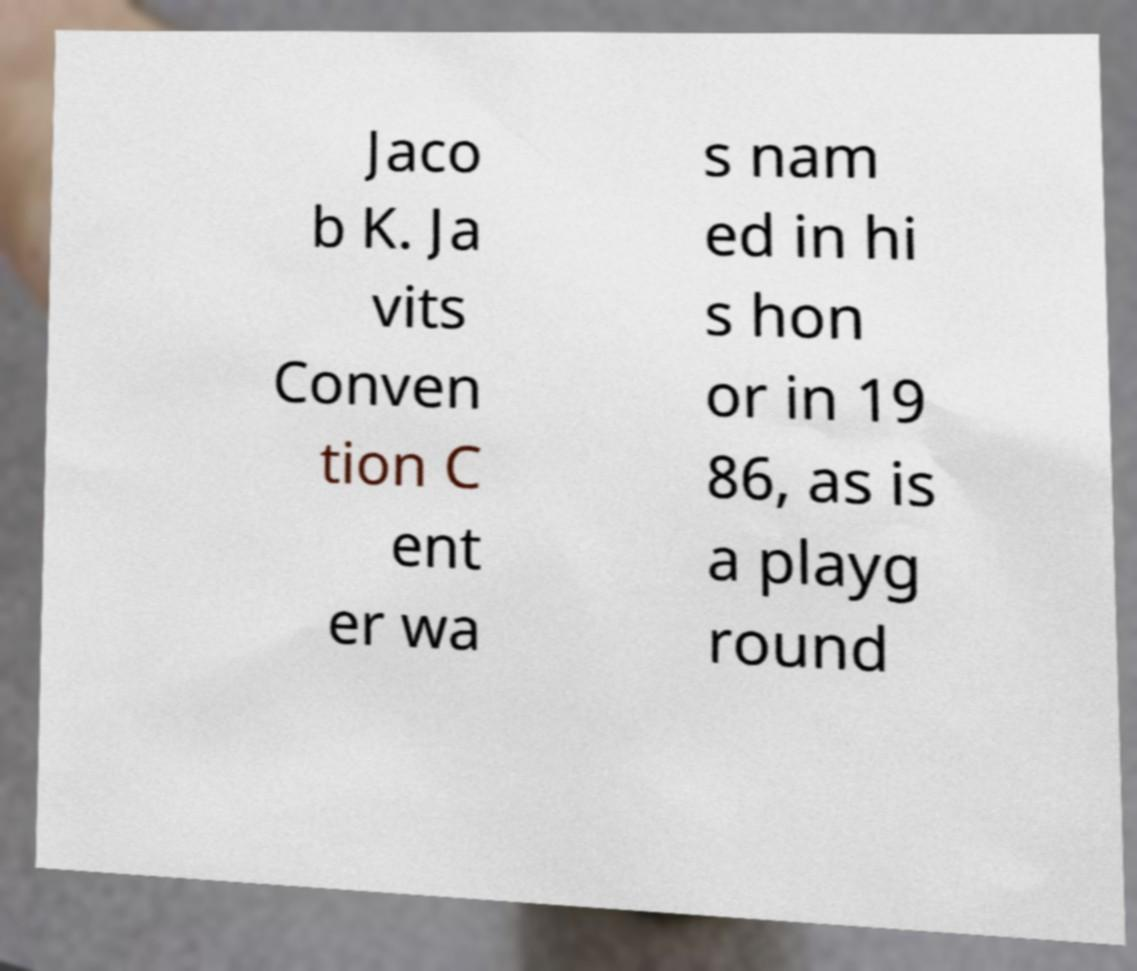Could you extract and type out the text from this image? Jaco b K. Ja vits Conven tion C ent er wa s nam ed in hi s hon or in 19 86, as is a playg round 